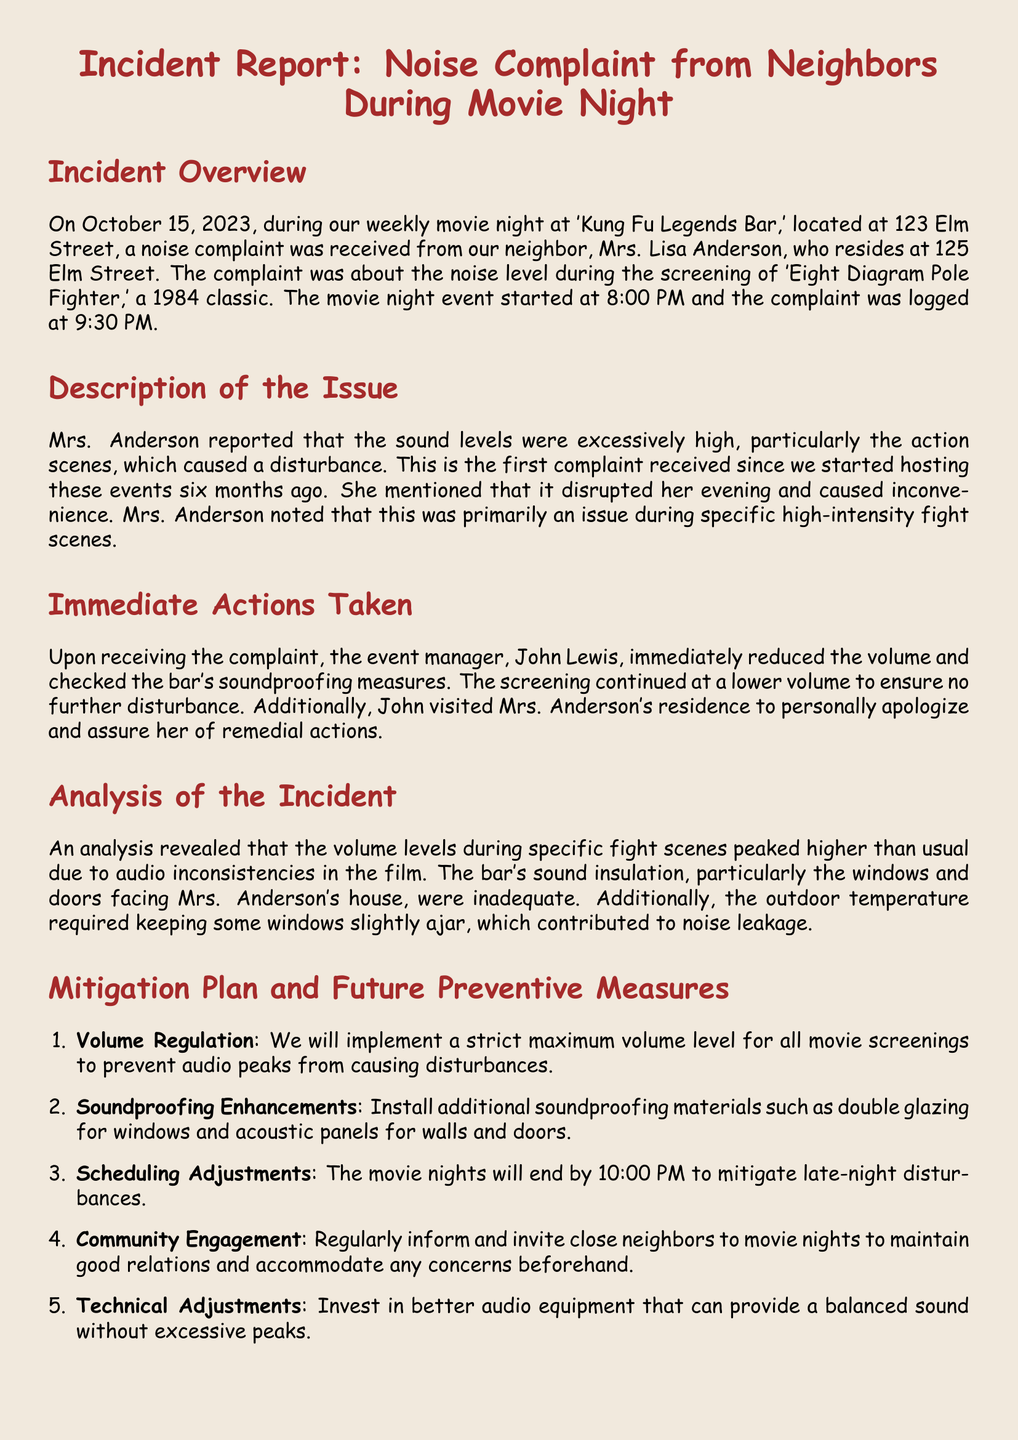What is the date of the incident? The date of the incident is mentioned at the beginning of the report in the overview section.
Answer: October 15, 2023 Who filed the noise complaint? The complainant's name is provided in the description of the issue section.
Answer: Mrs. Lisa Anderson What movie was being screened during the incident? The name of the movie is specified in the incident overview section.
Answer: Eight Diagram Pole Fighter At what time was the complaint logged? The time of the complaint is indicated in the overview section of the document.
Answer: 9:30 PM What immediate action was taken after the complaint? The document describes specific actions taken immediately following the complaint in the immediate actions taken section.
Answer: Reduced the volume What is one of the planned soundproofing enhancements? This information can be found in the mitigation plan section of the report.
Answer: Double glazing for windows What time will movie nights end moving forward? The new ending time for movie nights is stated in the mitigation plan section.
Answer: 10:00 PM What is the main issue reported by Mrs. Anderson? The document outlines the complainant's main concern in the description of the issue section.
Answer: Excessive noise levels What was the reaction of the event manager to the complaint? The report details how the event manager responded in the immediate actions taken section.
Answer: Personally apologize 